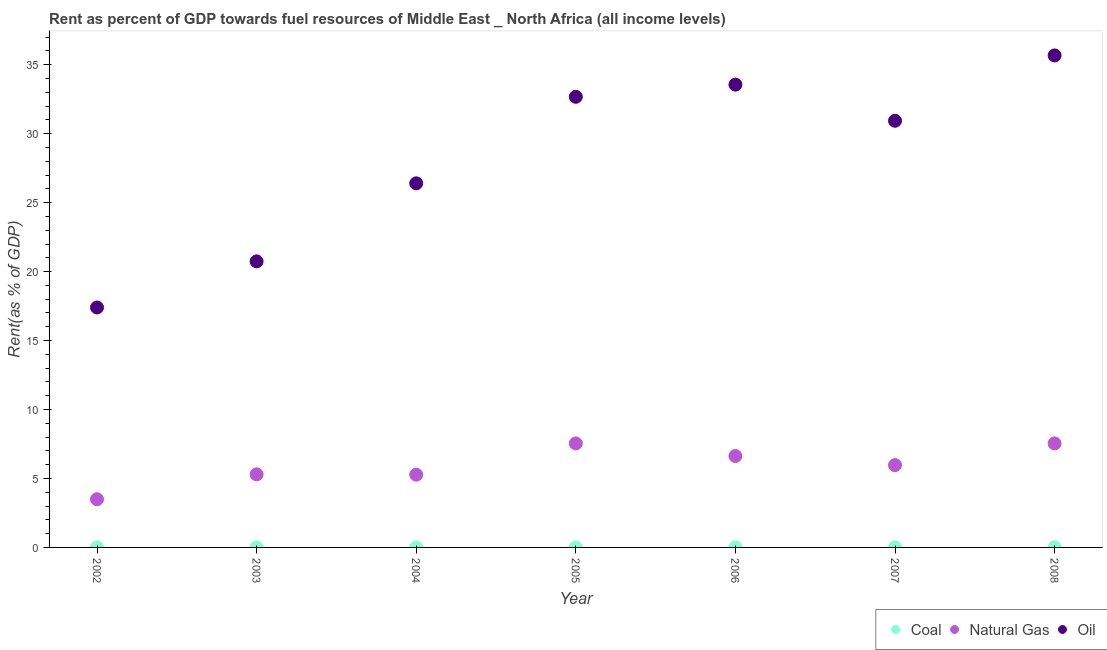Is the number of dotlines equal to the number of legend labels?
Make the answer very short. Yes. What is the rent towards natural gas in 2002?
Your answer should be compact. 3.49. Across all years, what is the maximum rent towards coal?
Keep it short and to the point. 0.01. Across all years, what is the minimum rent towards natural gas?
Your answer should be very brief. 3.49. In which year was the rent towards oil maximum?
Your answer should be very brief. 2008. In which year was the rent towards coal minimum?
Your response must be concise. 2002. What is the total rent towards oil in the graph?
Provide a short and direct response. 197.39. What is the difference between the rent towards natural gas in 2002 and that in 2008?
Offer a very short reply. -4.05. What is the difference between the rent towards oil in 2007 and the rent towards natural gas in 2004?
Your response must be concise. 25.66. What is the average rent towards coal per year?
Offer a very short reply. 0. In the year 2004, what is the difference between the rent towards coal and rent towards natural gas?
Give a very brief answer. -5.27. In how many years, is the rent towards coal greater than 33 %?
Ensure brevity in your answer.  0. What is the ratio of the rent towards oil in 2002 to that in 2007?
Provide a short and direct response. 0.56. Is the rent towards coal in 2004 less than that in 2008?
Make the answer very short. Yes. Is the difference between the rent towards natural gas in 2002 and 2003 greater than the difference between the rent towards oil in 2002 and 2003?
Keep it short and to the point. Yes. What is the difference between the highest and the second highest rent towards oil?
Offer a very short reply. 2.12. What is the difference between the highest and the lowest rent towards natural gas?
Make the answer very short. 4.05. Is it the case that in every year, the sum of the rent towards coal and rent towards natural gas is greater than the rent towards oil?
Ensure brevity in your answer.  No. Does the rent towards coal monotonically increase over the years?
Make the answer very short. No. Is the rent towards coal strictly greater than the rent towards natural gas over the years?
Your answer should be very brief. No. Is the rent towards oil strictly less than the rent towards natural gas over the years?
Keep it short and to the point. No. How many dotlines are there?
Offer a terse response. 3. What is the difference between two consecutive major ticks on the Y-axis?
Ensure brevity in your answer.  5. Are the values on the major ticks of Y-axis written in scientific E-notation?
Keep it short and to the point. No. Does the graph contain grids?
Your response must be concise. No. Where does the legend appear in the graph?
Provide a short and direct response. Bottom right. How many legend labels are there?
Your response must be concise. 3. What is the title of the graph?
Provide a short and direct response. Rent as percent of GDP towards fuel resources of Middle East _ North Africa (all income levels). What is the label or title of the Y-axis?
Your answer should be compact. Rent(as % of GDP). What is the Rent(as % of GDP) of Coal in 2002?
Give a very brief answer. 0. What is the Rent(as % of GDP) of Natural Gas in 2002?
Provide a succinct answer. 3.49. What is the Rent(as % of GDP) of Oil in 2002?
Offer a terse response. 17.4. What is the Rent(as % of GDP) in Coal in 2003?
Keep it short and to the point. 0. What is the Rent(as % of GDP) in Natural Gas in 2003?
Make the answer very short. 5.3. What is the Rent(as % of GDP) in Oil in 2003?
Provide a succinct answer. 20.74. What is the Rent(as % of GDP) of Coal in 2004?
Your answer should be very brief. 0. What is the Rent(as % of GDP) of Natural Gas in 2004?
Your response must be concise. 5.28. What is the Rent(as % of GDP) in Oil in 2004?
Ensure brevity in your answer.  26.4. What is the Rent(as % of GDP) of Coal in 2005?
Ensure brevity in your answer.  0. What is the Rent(as % of GDP) of Natural Gas in 2005?
Offer a terse response. 7.54. What is the Rent(as % of GDP) in Oil in 2005?
Make the answer very short. 32.67. What is the Rent(as % of GDP) of Coal in 2006?
Your answer should be very brief. 0. What is the Rent(as % of GDP) of Natural Gas in 2006?
Ensure brevity in your answer.  6.63. What is the Rent(as % of GDP) in Oil in 2006?
Ensure brevity in your answer.  33.56. What is the Rent(as % of GDP) in Coal in 2007?
Keep it short and to the point. 0. What is the Rent(as % of GDP) of Natural Gas in 2007?
Keep it short and to the point. 5.97. What is the Rent(as % of GDP) of Oil in 2007?
Ensure brevity in your answer.  30.94. What is the Rent(as % of GDP) of Coal in 2008?
Your response must be concise. 0.01. What is the Rent(as % of GDP) of Natural Gas in 2008?
Your answer should be very brief. 7.54. What is the Rent(as % of GDP) of Oil in 2008?
Offer a very short reply. 35.68. Across all years, what is the maximum Rent(as % of GDP) in Coal?
Give a very brief answer. 0.01. Across all years, what is the maximum Rent(as % of GDP) of Natural Gas?
Offer a terse response. 7.54. Across all years, what is the maximum Rent(as % of GDP) of Oil?
Your response must be concise. 35.68. Across all years, what is the minimum Rent(as % of GDP) in Coal?
Give a very brief answer. 0. Across all years, what is the minimum Rent(as % of GDP) in Natural Gas?
Keep it short and to the point. 3.49. Across all years, what is the minimum Rent(as % of GDP) of Oil?
Ensure brevity in your answer.  17.4. What is the total Rent(as % of GDP) in Coal in the graph?
Your answer should be very brief. 0.02. What is the total Rent(as % of GDP) of Natural Gas in the graph?
Make the answer very short. 41.75. What is the total Rent(as % of GDP) of Oil in the graph?
Provide a succinct answer. 197.39. What is the difference between the Rent(as % of GDP) in Coal in 2002 and that in 2003?
Offer a very short reply. -0. What is the difference between the Rent(as % of GDP) in Natural Gas in 2002 and that in 2003?
Your answer should be very brief. -1.81. What is the difference between the Rent(as % of GDP) of Oil in 2002 and that in 2003?
Your answer should be compact. -3.35. What is the difference between the Rent(as % of GDP) in Coal in 2002 and that in 2004?
Provide a succinct answer. -0. What is the difference between the Rent(as % of GDP) in Natural Gas in 2002 and that in 2004?
Offer a terse response. -1.78. What is the difference between the Rent(as % of GDP) in Oil in 2002 and that in 2004?
Your response must be concise. -9. What is the difference between the Rent(as % of GDP) of Coal in 2002 and that in 2005?
Your response must be concise. -0. What is the difference between the Rent(as % of GDP) in Natural Gas in 2002 and that in 2005?
Give a very brief answer. -4.05. What is the difference between the Rent(as % of GDP) in Oil in 2002 and that in 2005?
Provide a succinct answer. -15.28. What is the difference between the Rent(as % of GDP) of Coal in 2002 and that in 2006?
Ensure brevity in your answer.  -0. What is the difference between the Rent(as % of GDP) in Natural Gas in 2002 and that in 2006?
Make the answer very short. -3.13. What is the difference between the Rent(as % of GDP) of Oil in 2002 and that in 2006?
Make the answer very short. -16.16. What is the difference between the Rent(as % of GDP) in Coal in 2002 and that in 2007?
Provide a succinct answer. -0. What is the difference between the Rent(as % of GDP) in Natural Gas in 2002 and that in 2007?
Ensure brevity in your answer.  -2.48. What is the difference between the Rent(as % of GDP) of Oil in 2002 and that in 2007?
Ensure brevity in your answer.  -13.54. What is the difference between the Rent(as % of GDP) of Coal in 2002 and that in 2008?
Your answer should be very brief. -0.01. What is the difference between the Rent(as % of GDP) of Natural Gas in 2002 and that in 2008?
Offer a terse response. -4.05. What is the difference between the Rent(as % of GDP) of Oil in 2002 and that in 2008?
Offer a very short reply. -18.28. What is the difference between the Rent(as % of GDP) of Coal in 2003 and that in 2004?
Ensure brevity in your answer.  -0. What is the difference between the Rent(as % of GDP) of Natural Gas in 2003 and that in 2004?
Give a very brief answer. 0.02. What is the difference between the Rent(as % of GDP) of Oil in 2003 and that in 2004?
Your response must be concise. -5.66. What is the difference between the Rent(as % of GDP) in Coal in 2003 and that in 2005?
Give a very brief answer. -0. What is the difference between the Rent(as % of GDP) of Natural Gas in 2003 and that in 2005?
Offer a terse response. -2.24. What is the difference between the Rent(as % of GDP) in Oil in 2003 and that in 2005?
Your answer should be compact. -11.93. What is the difference between the Rent(as % of GDP) of Coal in 2003 and that in 2006?
Your answer should be very brief. -0. What is the difference between the Rent(as % of GDP) of Natural Gas in 2003 and that in 2006?
Give a very brief answer. -1.33. What is the difference between the Rent(as % of GDP) in Oil in 2003 and that in 2006?
Make the answer very short. -12.81. What is the difference between the Rent(as % of GDP) of Coal in 2003 and that in 2007?
Give a very brief answer. -0. What is the difference between the Rent(as % of GDP) in Natural Gas in 2003 and that in 2007?
Keep it short and to the point. -0.67. What is the difference between the Rent(as % of GDP) of Oil in 2003 and that in 2007?
Offer a terse response. -10.19. What is the difference between the Rent(as % of GDP) of Coal in 2003 and that in 2008?
Offer a very short reply. -0.01. What is the difference between the Rent(as % of GDP) of Natural Gas in 2003 and that in 2008?
Provide a short and direct response. -2.24. What is the difference between the Rent(as % of GDP) of Oil in 2003 and that in 2008?
Make the answer very short. -14.93. What is the difference between the Rent(as % of GDP) of Coal in 2004 and that in 2005?
Offer a very short reply. 0. What is the difference between the Rent(as % of GDP) in Natural Gas in 2004 and that in 2005?
Offer a terse response. -2.27. What is the difference between the Rent(as % of GDP) of Oil in 2004 and that in 2005?
Keep it short and to the point. -6.27. What is the difference between the Rent(as % of GDP) of Coal in 2004 and that in 2006?
Keep it short and to the point. 0. What is the difference between the Rent(as % of GDP) of Natural Gas in 2004 and that in 2006?
Make the answer very short. -1.35. What is the difference between the Rent(as % of GDP) in Oil in 2004 and that in 2006?
Offer a very short reply. -7.16. What is the difference between the Rent(as % of GDP) of Natural Gas in 2004 and that in 2007?
Give a very brief answer. -0.69. What is the difference between the Rent(as % of GDP) of Oil in 2004 and that in 2007?
Give a very brief answer. -4.54. What is the difference between the Rent(as % of GDP) in Coal in 2004 and that in 2008?
Your response must be concise. -0. What is the difference between the Rent(as % of GDP) in Natural Gas in 2004 and that in 2008?
Your response must be concise. -2.27. What is the difference between the Rent(as % of GDP) of Oil in 2004 and that in 2008?
Keep it short and to the point. -9.28. What is the difference between the Rent(as % of GDP) in Natural Gas in 2005 and that in 2006?
Your response must be concise. 0.91. What is the difference between the Rent(as % of GDP) in Oil in 2005 and that in 2006?
Your answer should be very brief. -0.88. What is the difference between the Rent(as % of GDP) of Coal in 2005 and that in 2007?
Give a very brief answer. -0. What is the difference between the Rent(as % of GDP) of Natural Gas in 2005 and that in 2007?
Give a very brief answer. 1.57. What is the difference between the Rent(as % of GDP) of Oil in 2005 and that in 2007?
Ensure brevity in your answer.  1.74. What is the difference between the Rent(as % of GDP) in Coal in 2005 and that in 2008?
Your answer should be very brief. -0. What is the difference between the Rent(as % of GDP) of Natural Gas in 2005 and that in 2008?
Give a very brief answer. -0. What is the difference between the Rent(as % of GDP) in Oil in 2005 and that in 2008?
Make the answer very short. -3. What is the difference between the Rent(as % of GDP) in Coal in 2006 and that in 2007?
Offer a terse response. -0. What is the difference between the Rent(as % of GDP) in Natural Gas in 2006 and that in 2007?
Keep it short and to the point. 0.66. What is the difference between the Rent(as % of GDP) in Oil in 2006 and that in 2007?
Your answer should be compact. 2.62. What is the difference between the Rent(as % of GDP) of Coal in 2006 and that in 2008?
Provide a short and direct response. -0. What is the difference between the Rent(as % of GDP) of Natural Gas in 2006 and that in 2008?
Ensure brevity in your answer.  -0.92. What is the difference between the Rent(as % of GDP) in Oil in 2006 and that in 2008?
Offer a very short reply. -2.12. What is the difference between the Rent(as % of GDP) in Coal in 2007 and that in 2008?
Your response must be concise. -0. What is the difference between the Rent(as % of GDP) of Natural Gas in 2007 and that in 2008?
Your response must be concise. -1.57. What is the difference between the Rent(as % of GDP) in Oil in 2007 and that in 2008?
Make the answer very short. -4.74. What is the difference between the Rent(as % of GDP) of Coal in 2002 and the Rent(as % of GDP) of Natural Gas in 2003?
Provide a succinct answer. -5.3. What is the difference between the Rent(as % of GDP) in Coal in 2002 and the Rent(as % of GDP) in Oil in 2003?
Offer a very short reply. -20.74. What is the difference between the Rent(as % of GDP) in Natural Gas in 2002 and the Rent(as % of GDP) in Oil in 2003?
Provide a short and direct response. -17.25. What is the difference between the Rent(as % of GDP) in Coal in 2002 and the Rent(as % of GDP) in Natural Gas in 2004?
Give a very brief answer. -5.27. What is the difference between the Rent(as % of GDP) in Coal in 2002 and the Rent(as % of GDP) in Oil in 2004?
Your answer should be compact. -26.4. What is the difference between the Rent(as % of GDP) of Natural Gas in 2002 and the Rent(as % of GDP) of Oil in 2004?
Provide a short and direct response. -22.91. What is the difference between the Rent(as % of GDP) in Coal in 2002 and the Rent(as % of GDP) in Natural Gas in 2005?
Offer a very short reply. -7.54. What is the difference between the Rent(as % of GDP) in Coal in 2002 and the Rent(as % of GDP) in Oil in 2005?
Make the answer very short. -32.67. What is the difference between the Rent(as % of GDP) of Natural Gas in 2002 and the Rent(as % of GDP) of Oil in 2005?
Offer a very short reply. -29.18. What is the difference between the Rent(as % of GDP) in Coal in 2002 and the Rent(as % of GDP) in Natural Gas in 2006?
Make the answer very short. -6.63. What is the difference between the Rent(as % of GDP) of Coal in 2002 and the Rent(as % of GDP) of Oil in 2006?
Your answer should be very brief. -33.56. What is the difference between the Rent(as % of GDP) of Natural Gas in 2002 and the Rent(as % of GDP) of Oil in 2006?
Make the answer very short. -30.06. What is the difference between the Rent(as % of GDP) in Coal in 2002 and the Rent(as % of GDP) in Natural Gas in 2007?
Offer a terse response. -5.97. What is the difference between the Rent(as % of GDP) of Coal in 2002 and the Rent(as % of GDP) of Oil in 2007?
Give a very brief answer. -30.94. What is the difference between the Rent(as % of GDP) in Natural Gas in 2002 and the Rent(as % of GDP) in Oil in 2007?
Provide a succinct answer. -27.44. What is the difference between the Rent(as % of GDP) in Coal in 2002 and the Rent(as % of GDP) in Natural Gas in 2008?
Your answer should be very brief. -7.54. What is the difference between the Rent(as % of GDP) in Coal in 2002 and the Rent(as % of GDP) in Oil in 2008?
Offer a terse response. -35.67. What is the difference between the Rent(as % of GDP) in Natural Gas in 2002 and the Rent(as % of GDP) in Oil in 2008?
Provide a succinct answer. -32.18. What is the difference between the Rent(as % of GDP) of Coal in 2003 and the Rent(as % of GDP) of Natural Gas in 2004?
Provide a succinct answer. -5.27. What is the difference between the Rent(as % of GDP) in Coal in 2003 and the Rent(as % of GDP) in Oil in 2004?
Provide a succinct answer. -26.4. What is the difference between the Rent(as % of GDP) in Natural Gas in 2003 and the Rent(as % of GDP) in Oil in 2004?
Ensure brevity in your answer.  -21.1. What is the difference between the Rent(as % of GDP) in Coal in 2003 and the Rent(as % of GDP) in Natural Gas in 2005?
Provide a short and direct response. -7.54. What is the difference between the Rent(as % of GDP) of Coal in 2003 and the Rent(as % of GDP) of Oil in 2005?
Make the answer very short. -32.67. What is the difference between the Rent(as % of GDP) in Natural Gas in 2003 and the Rent(as % of GDP) in Oil in 2005?
Offer a terse response. -27.38. What is the difference between the Rent(as % of GDP) in Coal in 2003 and the Rent(as % of GDP) in Natural Gas in 2006?
Your answer should be very brief. -6.63. What is the difference between the Rent(as % of GDP) of Coal in 2003 and the Rent(as % of GDP) of Oil in 2006?
Ensure brevity in your answer.  -33.56. What is the difference between the Rent(as % of GDP) of Natural Gas in 2003 and the Rent(as % of GDP) of Oil in 2006?
Your answer should be very brief. -28.26. What is the difference between the Rent(as % of GDP) in Coal in 2003 and the Rent(as % of GDP) in Natural Gas in 2007?
Offer a very short reply. -5.97. What is the difference between the Rent(as % of GDP) of Coal in 2003 and the Rent(as % of GDP) of Oil in 2007?
Your answer should be very brief. -30.94. What is the difference between the Rent(as % of GDP) in Natural Gas in 2003 and the Rent(as % of GDP) in Oil in 2007?
Provide a succinct answer. -25.64. What is the difference between the Rent(as % of GDP) of Coal in 2003 and the Rent(as % of GDP) of Natural Gas in 2008?
Provide a short and direct response. -7.54. What is the difference between the Rent(as % of GDP) of Coal in 2003 and the Rent(as % of GDP) of Oil in 2008?
Offer a terse response. -35.67. What is the difference between the Rent(as % of GDP) in Natural Gas in 2003 and the Rent(as % of GDP) in Oil in 2008?
Provide a short and direct response. -30.38. What is the difference between the Rent(as % of GDP) of Coal in 2004 and the Rent(as % of GDP) of Natural Gas in 2005?
Offer a very short reply. -7.54. What is the difference between the Rent(as % of GDP) in Coal in 2004 and the Rent(as % of GDP) in Oil in 2005?
Provide a short and direct response. -32.67. What is the difference between the Rent(as % of GDP) in Natural Gas in 2004 and the Rent(as % of GDP) in Oil in 2005?
Your answer should be compact. -27.4. What is the difference between the Rent(as % of GDP) of Coal in 2004 and the Rent(as % of GDP) of Natural Gas in 2006?
Offer a very short reply. -6.62. What is the difference between the Rent(as % of GDP) of Coal in 2004 and the Rent(as % of GDP) of Oil in 2006?
Your answer should be very brief. -33.55. What is the difference between the Rent(as % of GDP) of Natural Gas in 2004 and the Rent(as % of GDP) of Oil in 2006?
Provide a succinct answer. -28.28. What is the difference between the Rent(as % of GDP) in Coal in 2004 and the Rent(as % of GDP) in Natural Gas in 2007?
Ensure brevity in your answer.  -5.96. What is the difference between the Rent(as % of GDP) of Coal in 2004 and the Rent(as % of GDP) of Oil in 2007?
Your response must be concise. -30.93. What is the difference between the Rent(as % of GDP) in Natural Gas in 2004 and the Rent(as % of GDP) in Oil in 2007?
Make the answer very short. -25.66. What is the difference between the Rent(as % of GDP) in Coal in 2004 and the Rent(as % of GDP) in Natural Gas in 2008?
Offer a terse response. -7.54. What is the difference between the Rent(as % of GDP) in Coal in 2004 and the Rent(as % of GDP) in Oil in 2008?
Offer a very short reply. -35.67. What is the difference between the Rent(as % of GDP) of Natural Gas in 2004 and the Rent(as % of GDP) of Oil in 2008?
Offer a very short reply. -30.4. What is the difference between the Rent(as % of GDP) in Coal in 2005 and the Rent(as % of GDP) in Natural Gas in 2006?
Make the answer very short. -6.62. What is the difference between the Rent(as % of GDP) of Coal in 2005 and the Rent(as % of GDP) of Oil in 2006?
Offer a terse response. -33.55. What is the difference between the Rent(as % of GDP) of Natural Gas in 2005 and the Rent(as % of GDP) of Oil in 2006?
Keep it short and to the point. -26.02. What is the difference between the Rent(as % of GDP) in Coal in 2005 and the Rent(as % of GDP) in Natural Gas in 2007?
Ensure brevity in your answer.  -5.97. What is the difference between the Rent(as % of GDP) in Coal in 2005 and the Rent(as % of GDP) in Oil in 2007?
Provide a short and direct response. -30.93. What is the difference between the Rent(as % of GDP) of Natural Gas in 2005 and the Rent(as % of GDP) of Oil in 2007?
Your response must be concise. -23.4. What is the difference between the Rent(as % of GDP) of Coal in 2005 and the Rent(as % of GDP) of Natural Gas in 2008?
Offer a terse response. -7.54. What is the difference between the Rent(as % of GDP) of Coal in 2005 and the Rent(as % of GDP) of Oil in 2008?
Keep it short and to the point. -35.67. What is the difference between the Rent(as % of GDP) of Natural Gas in 2005 and the Rent(as % of GDP) of Oil in 2008?
Give a very brief answer. -28.13. What is the difference between the Rent(as % of GDP) of Coal in 2006 and the Rent(as % of GDP) of Natural Gas in 2007?
Offer a terse response. -5.97. What is the difference between the Rent(as % of GDP) of Coal in 2006 and the Rent(as % of GDP) of Oil in 2007?
Your answer should be very brief. -30.93. What is the difference between the Rent(as % of GDP) in Natural Gas in 2006 and the Rent(as % of GDP) in Oil in 2007?
Your response must be concise. -24.31. What is the difference between the Rent(as % of GDP) of Coal in 2006 and the Rent(as % of GDP) of Natural Gas in 2008?
Offer a very short reply. -7.54. What is the difference between the Rent(as % of GDP) in Coal in 2006 and the Rent(as % of GDP) in Oil in 2008?
Keep it short and to the point. -35.67. What is the difference between the Rent(as % of GDP) in Natural Gas in 2006 and the Rent(as % of GDP) in Oil in 2008?
Your response must be concise. -29.05. What is the difference between the Rent(as % of GDP) of Coal in 2007 and the Rent(as % of GDP) of Natural Gas in 2008?
Offer a very short reply. -7.54. What is the difference between the Rent(as % of GDP) in Coal in 2007 and the Rent(as % of GDP) in Oil in 2008?
Your answer should be very brief. -35.67. What is the difference between the Rent(as % of GDP) of Natural Gas in 2007 and the Rent(as % of GDP) of Oil in 2008?
Your answer should be very brief. -29.71. What is the average Rent(as % of GDP) in Coal per year?
Ensure brevity in your answer.  0. What is the average Rent(as % of GDP) of Natural Gas per year?
Provide a short and direct response. 5.96. What is the average Rent(as % of GDP) of Oil per year?
Your answer should be very brief. 28.2. In the year 2002, what is the difference between the Rent(as % of GDP) of Coal and Rent(as % of GDP) of Natural Gas?
Provide a succinct answer. -3.49. In the year 2002, what is the difference between the Rent(as % of GDP) in Coal and Rent(as % of GDP) in Oil?
Give a very brief answer. -17.4. In the year 2002, what is the difference between the Rent(as % of GDP) in Natural Gas and Rent(as % of GDP) in Oil?
Your answer should be compact. -13.9. In the year 2003, what is the difference between the Rent(as % of GDP) of Coal and Rent(as % of GDP) of Natural Gas?
Provide a succinct answer. -5.3. In the year 2003, what is the difference between the Rent(as % of GDP) of Coal and Rent(as % of GDP) of Oil?
Your answer should be compact. -20.74. In the year 2003, what is the difference between the Rent(as % of GDP) of Natural Gas and Rent(as % of GDP) of Oil?
Provide a short and direct response. -15.44. In the year 2004, what is the difference between the Rent(as % of GDP) in Coal and Rent(as % of GDP) in Natural Gas?
Offer a very short reply. -5.27. In the year 2004, what is the difference between the Rent(as % of GDP) of Coal and Rent(as % of GDP) of Oil?
Offer a terse response. -26.4. In the year 2004, what is the difference between the Rent(as % of GDP) of Natural Gas and Rent(as % of GDP) of Oil?
Your response must be concise. -21.12. In the year 2005, what is the difference between the Rent(as % of GDP) in Coal and Rent(as % of GDP) in Natural Gas?
Give a very brief answer. -7.54. In the year 2005, what is the difference between the Rent(as % of GDP) in Coal and Rent(as % of GDP) in Oil?
Your answer should be compact. -32.67. In the year 2005, what is the difference between the Rent(as % of GDP) in Natural Gas and Rent(as % of GDP) in Oil?
Ensure brevity in your answer.  -25.13. In the year 2006, what is the difference between the Rent(as % of GDP) in Coal and Rent(as % of GDP) in Natural Gas?
Give a very brief answer. -6.63. In the year 2006, what is the difference between the Rent(as % of GDP) in Coal and Rent(as % of GDP) in Oil?
Your response must be concise. -33.55. In the year 2006, what is the difference between the Rent(as % of GDP) in Natural Gas and Rent(as % of GDP) in Oil?
Your answer should be compact. -26.93. In the year 2007, what is the difference between the Rent(as % of GDP) in Coal and Rent(as % of GDP) in Natural Gas?
Your response must be concise. -5.96. In the year 2007, what is the difference between the Rent(as % of GDP) of Coal and Rent(as % of GDP) of Oil?
Provide a short and direct response. -30.93. In the year 2007, what is the difference between the Rent(as % of GDP) in Natural Gas and Rent(as % of GDP) in Oil?
Provide a short and direct response. -24.97. In the year 2008, what is the difference between the Rent(as % of GDP) in Coal and Rent(as % of GDP) in Natural Gas?
Your response must be concise. -7.54. In the year 2008, what is the difference between the Rent(as % of GDP) of Coal and Rent(as % of GDP) of Oil?
Your response must be concise. -35.67. In the year 2008, what is the difference between the Rent(as % of GDP) in Natural Gas and Rent(as % of GDP) in Oil?
Give a very brief answer. -28.13. What is the ratio of the Rent(as % of GDP) of Coal in 2002 to that in 2003?
Ensure brevity in your answer.  0.65. What is the ratio of the Rent(as % of GDP) of Natural Gas in 2002 to that in 2003?
Your answer should be very brief. 0.66. What is the ratio of the Rent(as % of GDP) in Oil in 2002 to that in 2003?
Provide a succinct answer. 0.84. What is the ratio of the Rent(as % of GDP) in Coal in 2002 to that in 2004?
Your answer should be very brief. 0.15. What is the ratio of the Rent(as % of GDP) in Natural Gas in 2002 to that in 2004?
Your answer should be compact. 0.66. What is the ratio of the Rent(as % of GDP) of Oil in 2002 to that in 2004?
Your answer should be compact. 0.66. What is the ratio of the Rent(as % of GDP) of Coal in 2002 to that in 2005?
Provide a succinct answer. 0.2. What is the ratio of the Rent(as % of GDP) in Natural Gas in 2002 to that in 2005?
Offer a terse response. 0.46. What is the ratio of the Rent(as % of GDP) of Oil in 2002 to that in 2005?
Your response must be concise. 0.53. What is the ratio of the Rent(as % of GDP) in Coal in 2002 to that in 2006?
Ensure brevity in your answer.  0.22. What is the ratio of the Rent(as % of GDP) of Natural Gas in 2002 to that in 2006?
Your response must be concise. 0.53. What is the ratio of the Rent(as % of GDP) in Oil in 2002 to that in 2006?
Give a very brief answer. 0.52. What is the ratio of the Rent(as % of GDP) of Coal in 2002 to that in 2007?
Your response must be concise. 0.17. What is the ratio of the Rent(as % of GDP) of Natural Gas in 2002 to that in 2007?
Offer a very short reply. 0.59. What is the ratio of the Rent(as % of GDP) in Oil in 2002 to that in 2007?
Offer a very short reply. 0.56. What is the ratio of the Rent(as % of GDP) of Coal in 2002 to that in 2008?
Your answer should be compact. 0.08. What is the ratio of the Rent(as % of GDP) in Natural Gas in 2002 to that in 2008?
Offer a terse response. 0.46. What is the ratio of the Rent(as % of GDP) of Oil in 2002 to that in 2008?
Offer a very short reply. 0.49. What is the ratio of the Rent(as % of GDP) of Coal in 2003 to that in 2004?
Your response must be concise. 0.23. What is the ratio of the Rent(as % of GDP) in Oil in 2003 to that in 2004?
Keep it short and to the point. 0.79. What is the ratio of the Rent(as % of GDP) in Coal in 2003 to that in 2005?
Provide a succinct answer. 0.31. What is the ratio of the Rent(as % of GDP) in Natural Gas in 2003 to that in 2005?
Your answer should be compact. 0.7. What is the ratio of the Rent(as % of GDP) of Oil in 2003 to that in 2005?
Provide a short and direct response. 0.63. What is the ratio of the Rent(as % of GDP) in Coal in 2003 to that in 2006?
Keep it short and to the point. 0.33. What is the ratio of the Rent(as % of GDP) in Natural Gas in 2003 to that in 2006?
Provide a short and direct response. 0.8. What is the ratio of the Rent(as % of GDP) of Oil in 2003 to that in 2006?
Ensure brevity in your answer.  0.62. What is the ratio of the Rent(as % of GDP) in Coal in 2003 to that in 2007?
Offer a terse response. 0.26. What is the ratio of the Rent(as % of GDP) in Natural Gas in 2003 to that in 2007?
Provide a short and direct response. 0.89. What is the ratio of the Rent(as % of GDP) of Oil in 2003 to that in 2007?
Provide a succinct answer. 0.67. What is the ratio of the Rent(as % of GDP) in Coal in 2003 to that in 2008?
Your answer should be compact. 0.12. What is the ratio of the Rent(as % of GDP) in Natural Gas in 2003 to that in 2008?
Keep it short and to the point. 0.7. What is the ratio of the Rent(as % of GDP) of Oil in 2003 to that in 2008?
Make the answer very short. 0.58. What is the ratio of the Rent(as % of GDP) in Coal in 2004 to that in 2005?
Your answer should be compact. 1.32. What is the ratio of the Rent(as % of GDP) of Natural Gas in 2004 to that in 2005?
Provide a succinct answer. 0.7. What is the ratio of the Rent(as % of GDP) of Oil in 2004 to that in 2005?
Your response must be concise. 0.81. What is the ratio of the Rent(as % of GDP) of Coal in 2004 to that in 2006?
Keep it short and to the point. 1.43. What is the ratio of the Rent(as % of GDP) of Natural Gas in 2004 to that in 2006?
Offer a terse response. 0.8. What is the ratio of the Rent(as % of GDP) in Oil in 2004 to that in 2006?
Your answer should be compact. 0.79. What is the ratio of the Rent(as % of GDP) in Coal in 2004 to that in 2007?
Your response must be concise. 1.1. What is the ratio of the Rent(as % of GDP) of Natural Gas in 2004 to that in 2007?
Your response must be concise. 0.88. What is the ratio of the Rent(as % of GDP) of Oil in 2004 to that in 2007?
Keep it short and to the point. 0.85. What is the ratio of the Rent(as % of GDP) in Coal in 2004 to that in 2008?
Ensure brevity in your answer.  0.53. What is the ratio of the Rent(as % of GDP) of Natural Gas in 2004 to that in 2008?
Make the answer very short. 0.7. What is the ratio of the Rent(as % of GDP) in Oil in 2004 to that in 2008?
Your response must be concise. 0.74. What is the ratio of the Rent(as % of GDP) in Coal in 2005 to that in 2006?
Keep it short and to the point. 1.08. What is the ratio of the Rent(as % of GDP) of Natural Gas in 2005 to that in 2006?
Offer a terse response. 1.14. What is the ratio of the Rent(as % of GDP) of Oil in 2005 to that in 2006?
Provide a succinct answer. 0.97. What is the ratio of the Rent(as % of GDP) of Coal in 2005 to that in 2007?
Offer a very short reply. 0.84. What is the ratio of the Rent(as % of GDP) in Natural Gas in 2005 to that in 2007?
Your answer should be very brief. 1.26. What is the ratio of the Rent(as % of GDP) of Oil in 2005 to that in 2007?
Make the answer very short. 1.06. What is the ratio of the Rent(as % of GDP) in Coal in 2005 to that in 2008?
Your answer should be very brief. 0.4. What is the ratio of the Rent(as % of GDP) in Natural Gas in 2005 to that in 2008?
Your answer should be compact. 1. What is the ratio of the Rent(as % of GDP) in Oil in 2005 to that in 2008?
Your answer should be compact. 0.92. What is the ratio of the Rent(as % of GDP) in Coal in 2006 to that in 2007?
Provide a succinct answer. 0.77. What is the ratio of the Rent(as % of GDP) in Natural Gas in 2006 to that in 2007?
Give a very brief answer. 1.11. What is the ratio of the Rent(as % of GDP) of Oil in 2006 to that in 2007?
Ensure brevity in your answer.  1.08. What is the ratio of the Rent(as % of GDP) in Coal in 2006 to that in 2008?
Provide a succinct answer. 0.37. What is the ratio of the Rent(as % of GDP) of Natural Gas in 2006 to that in 2008?
Provide a short and direct response. 0.88. What is the ratio of the Rent(as % of GDP) of Oil in 2006 to that in 2008?
Offer a very short reply. 0.94. What is the ratio of the Rent(as % of GDP) in Coal in 2007 to that in 2008?
Offer a very short reply. 0.48. What is the ratio of the Rent(as % of GDP) in Natural Gas in 2007 to that in 2008?
Offer a very short reply. 0.79. What is the ratio of the Rent(as % of GDP) in Oil in 2007 to that in 2008?
Provide a succinct answer. 0.87. What is the difference between the highest and the second highest Rent(as % of GDP) in Coal?
Give a very brief answer. 0. What is the difference between the highest and the second highest Rent(as % of GDP) in Natural Gas?
Your answer should be very brief. 0. What is the difference between the highest and the second highest Rent(as % of GDP) in Oil?
Offer a very short reply. 2.12. What is the difference between the highest and the lowest Rent(as % of GDP) in Coal?
Keep it short and to the point. 0.01. What is the difference between the highest and the lowest Rent(as % of GDP) in Natural Gas?
Your answer should be very brief. 4.05. What is the difference between the highest and the lowest Rent(as % of GDP) of Oil?
Ensure brevity in your answer.  18.28. 